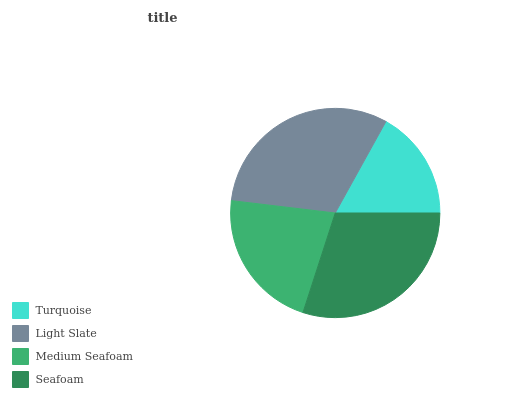Is Turquoise the minimum?
Answer yes or no. Yes. Is Light Slate the maximum?
Answer yes or no. Yes. Is Medium Seafoam the minimum?
Answer yes or no. No. Is Medium Seafoam the maximum?
Answer yes or no. No. Is Light Slate greater than Medium Seafoam?
Answer yes or no. Yes. Is Medium Seafoam less than Light Slate?
Answer yes or no. Yes. Is Medium Seafoam greater than Light Slate?
Answer yes or no. No. Is Light Slate less than Medium Seafoam?
Answer yes or no. No. Is Seafoam the high median?
Answer yes or no. Yes. Is Medium Seafoam the low median?
Answer yes or no. Yes. Is Turquoise the high median?
Answer yes or no. No. Is Turquoise the low median?
Answer yes or no. No. 